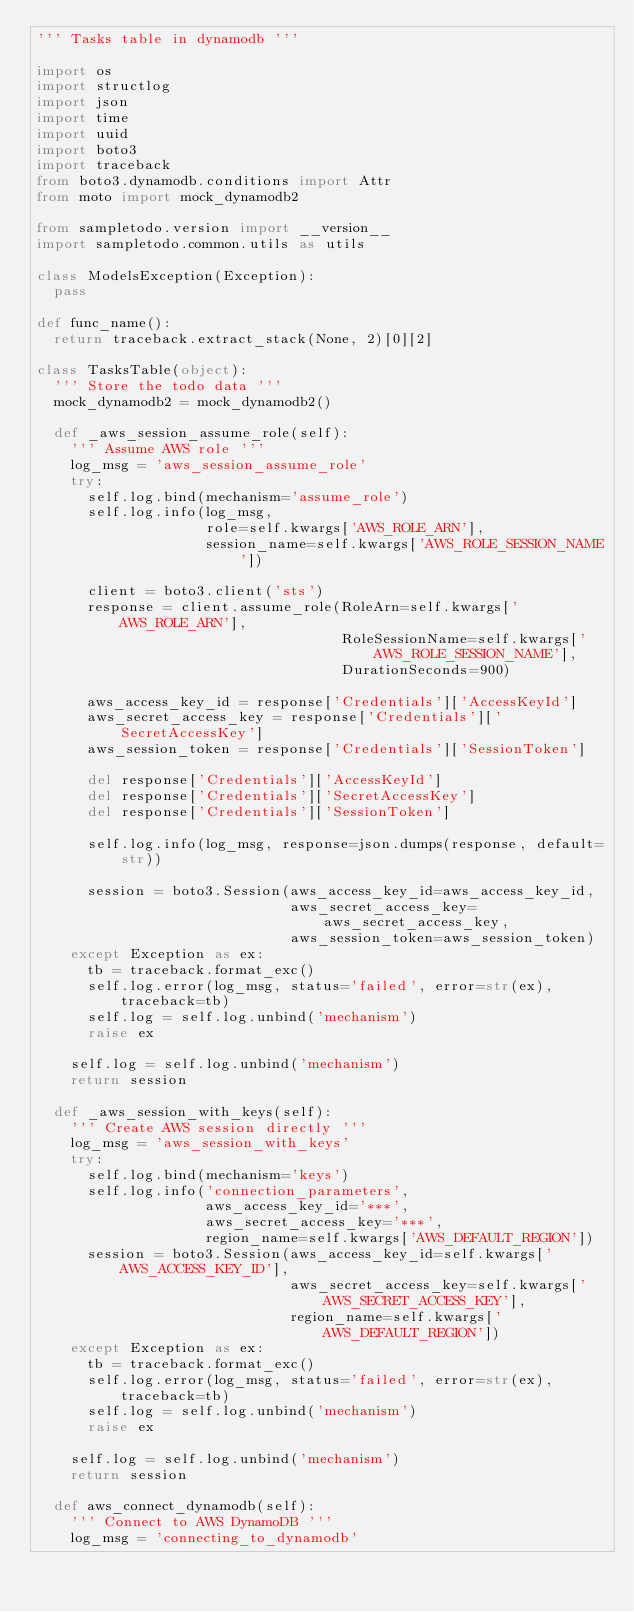<code> <loc_0><loc_0><loc_500><loc_500><_Python_>''' Tasks table in dynamodb '''

import os
import structlog
import json
import time
import uuid
import boto3
import traceback
from boto3.dynamodb.conditions import Attr
from moto import mock_dynamodb2

from sampletodo.version import __version__
import sampletodo.common.utils as utils

class ModelsException(Exception):
  pass

def func_name():
  return traceback.extract_stack(None, 2)[0][2]

class TasksTable(object):
  ''' Store the todo data '''
  mock_dynamodb2 = mock_dynamodb2()

  def _aws_session_assume_role(self):
    ''' Assume AWS role '''
    log_msg = 'aws_session_assume_role'
    try:
      self.log.bind(mechanism='assume_role')
      self.log.info(log_msg,
                    role=self.kwargs['AWS_ROLE_ARN'],
                    session_name=self.kwargs['AWS_ROLE_SESSION_NAME'])

      client = boto3.client('sts')
      response = client.assume_role(RoleArn=self.kwargs['AWS_ROLE_ARN'],
                                    RoleSessionName=self.kwargs['AWS_ROLE_SESSION_NAME'],
                                    DurationSeconds=900)

      aws_access_key_id = response['Credentials']['AccessKeyId']
      aws_secret_access_key = response['Credentials']['SecretAccessKey']
      aws_session_token = response['Credentials']['SessionToken']

      del response['Credentials']['AccessKeyId']
      del response['Credentials']['SecretAccessKey']
      del response['Credentials']['SessionToken']

      self.log.info(log_msg, response=json.dumps(response, default=str))

      session = boto3.Session(aws_access_key_id=aws_access_key_id,
                              aws_secret_access_key=aws_secret_access_key,
                              aws_session_token=aws_session_token)
    except Exception as ex:
      tb = traceback.format_exc()
      self.log.error(log_msg, status='failed', error=str(ex), traceback=tb)
      self.log = self.log.unbind('mechanism')
      raise ex

    self.log = self.log.unbind('mechanism')
    return session

  def _aws_session_with_keys(self):
    ''' Create AWS session directly '''
    log_msg = 'aws_session_with_keys'
    try:
      self.log.bind(mechanism='keys')
      self.log.info('connection_parameters',
                    aws_access_key_id='***',
                    aws_secret_access_key='***',
                    region_name=self.kwargs['AWS_DEFAULT_REGION'])
      session = boto3.Session(aws_access_key_id=self.kwargs['AWS_ACCESS_KEY_ID'],
                              aws_secret_access_key=self.kwargs['AWS_SECRET_ACCESS_KEY'],
                              region_name=self.kwargs['AWS_DEFAULT_REGION'])
    except Exception as ex:
      tb = traceback.format_exc()
      self.log.error(log_msg, status='failed', error=str(ex), traceback=tb)
      self.log = self.log.unbind('mechanism')
      raise ex

    self.log = self.log.unbind('mechanism')
    return session

  def aws_connect_dynamodb(self):
    ''' Connect to AWS DynamoDB '''
    log_msg = 'connecting_to_dynamodb'</code> 